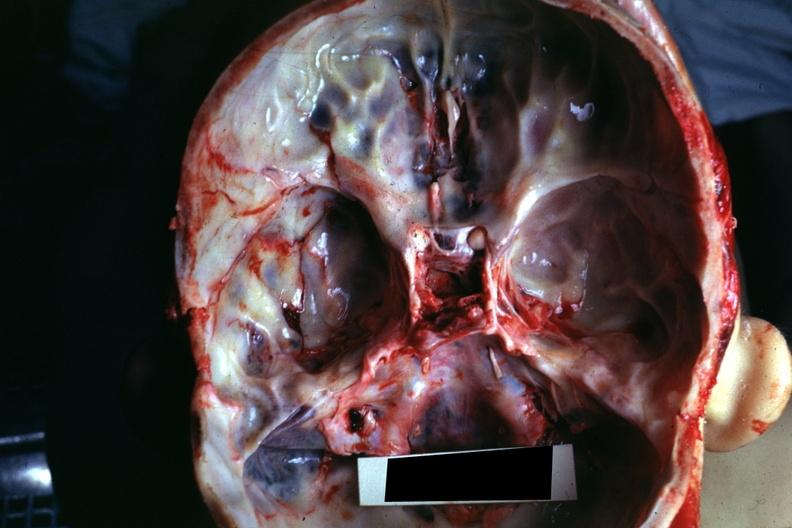s basilar skull fracture present?
Answer the question using a single word or phrase. Yes 